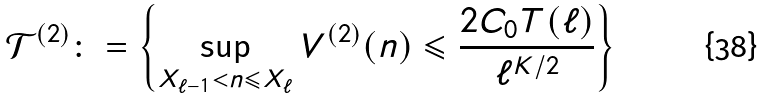<formula> <loc_0><loc_0><loc_500><loc_500>\mathcal { T } ^ { ( 2 ) } \colon = \left \{ \sup _ { X _ { \ell - 1 } < n \leqslant X _ { \ell } } V ^ { ( 2 ) } ( n ) \leqslant \frac { 2 C _ { 0 } T ( \ell ) } { \ell ^ { K / 2 } } \right \}</formula> 